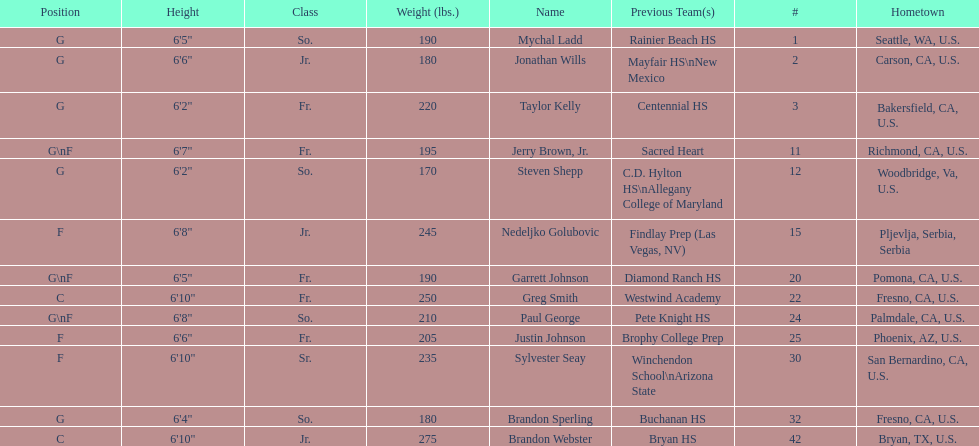Between paul george and greg smith, who has a greater height? Greg Smith. 